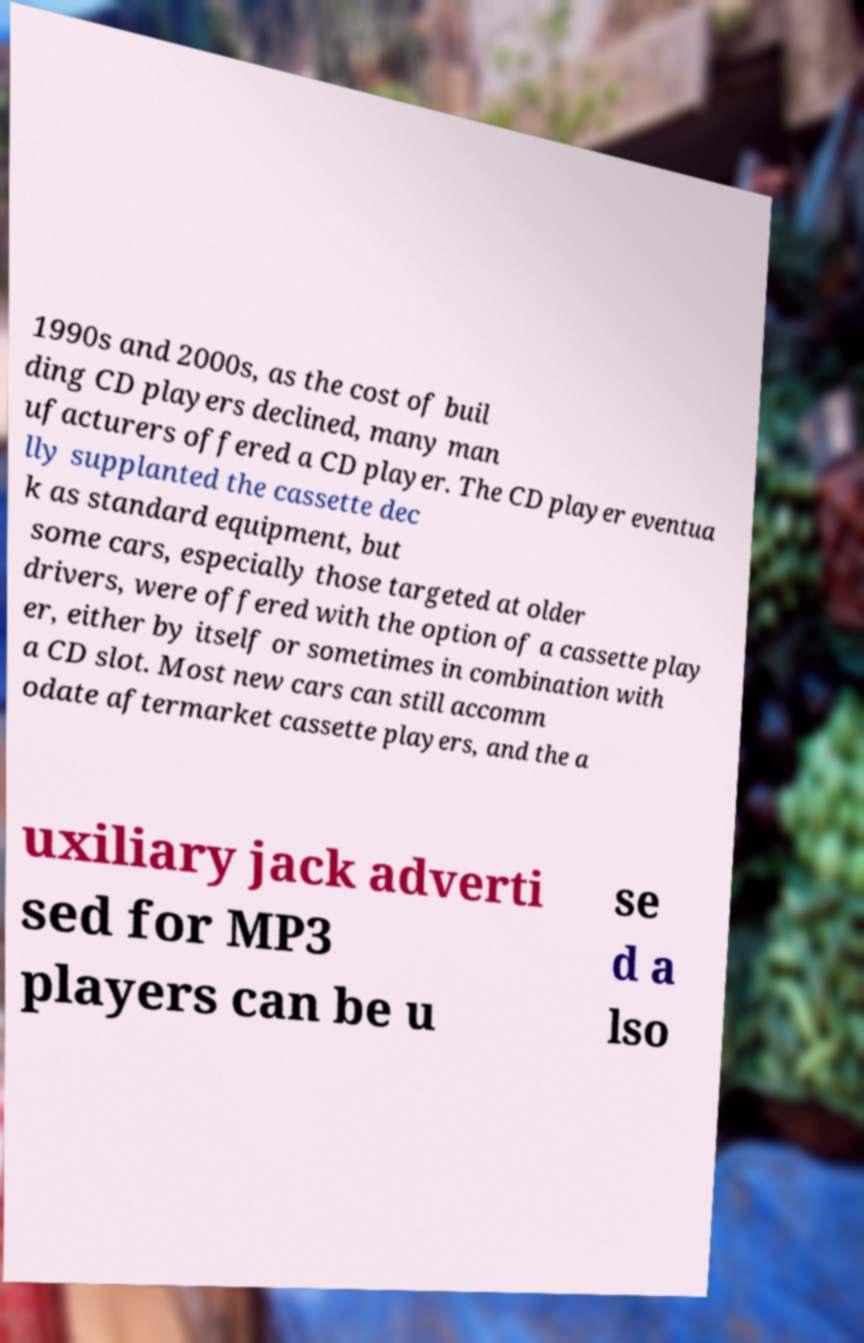For documentation purposes, I need the text within this image transcribed. Could you provide that? 1990s and 2000s, as the cost of buil ding CD players declined, many man ufacturers offered a CD player. The CD player eventua lly supplanted the cassette dec k as standard equipment, but some cars, especially those targeted at older drivers, were offered with the option of a cassette play er, either by itself or sometimes in combination with a CD slot. Most new cars can still accomm odate aftermarket cassette players, and the a uxiliary jack adverti sed for MP3 players can be u se d a lso 